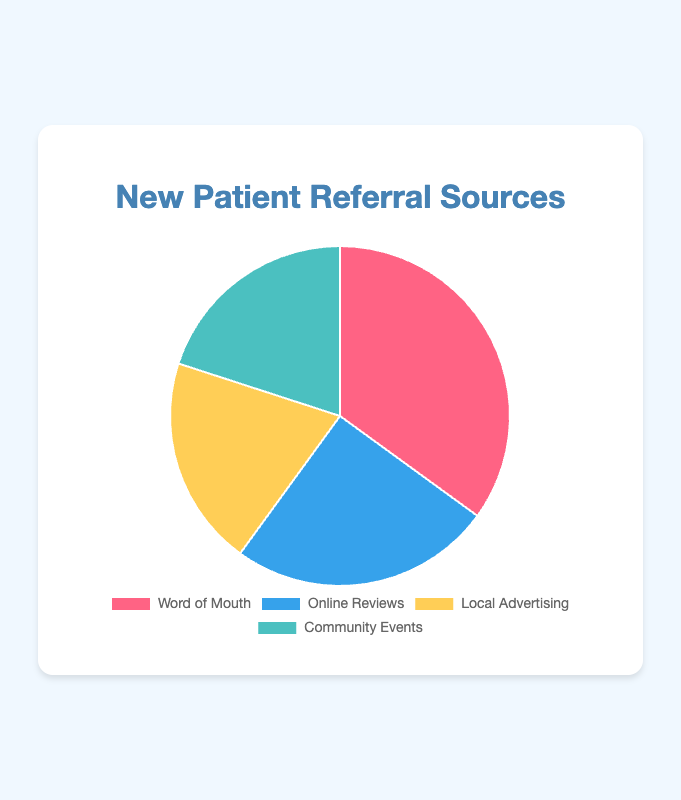What percentage of new patient referrals come from Word of Mouth? By examining the figure, the slice representing Word of Mouth referrals occupies 35% of the pie chart.
Answer: 35% Which referral source contributes the least to new patient referrals? The figure shows that Local Advertising and Community Events both occupy the smallest slices, each representing 20%. These are the least contributors.
Answer: Local Advertising and Community Events How much more do Word of Mouth referrals contribute compared to Online Reviews? The figure indicates Word of Mouth referrals are 35%, and Online Reviews are 25%. The difference is 35% - 25% = 10%.
Answer: 10% What is the combined percentage of patient referrals from Local Advertising and Community Events? According to the figure, Local Advertising contributes 20% and Community Events also contribute 20%. Their combined contribution is 20% + 20% = 40%.
Answer: 40% Which referral source is represented by the blue section of the pie chart? The visual attributes of the pie chart show that the blue section represents Online Reviews.
Answer: Online Reviews If the percentages for Local Advertising and Community Events were combined into a single category, how would this new category compare to Word of Mouth in terms of percentage points? Local Advertising and Community Events each contribute 20%, summing to 40%. Word of Mouth contributes 35%, so the new combined category is 40% - 35% = 5% higher.
Answer: 5% higher Rank the referral sources from highest to lowest based on their percentages. By looking at the figure, the rankings are: 
1. Word of Mouth: 35%
2. Online Reviews: 25%
3. (tied) Local Advertising and Community Events: 20% each
Answer: Word of Mouth, Online Reviews, Local Advertising/Community Events What percentage of new patient referrals don't come from Word of Mouth? Since Word of Mouth contributes 35%, the remaining percentage is 100% - 35% = 65%.
Answer: 65% If the Community Events contributed 5% more, which data source would have the highest percentage? Increasing the Community Events' percentage from 20% to 25% would make it equal to Online Reviews. However, Word of Mouth remains the highest at 35%.
Answer: Word of Mouth 